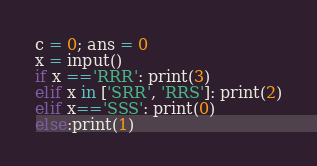<code> <loc_0><loc_0><loc_500><loc_500><_Python_>c = 0; ans = 0
x = input()
if x =='RRR': print(3)
elif x in ['SRR', 'RRS']: print(2)
elif x=='SSS': print(0)
else:print(1)</code> 